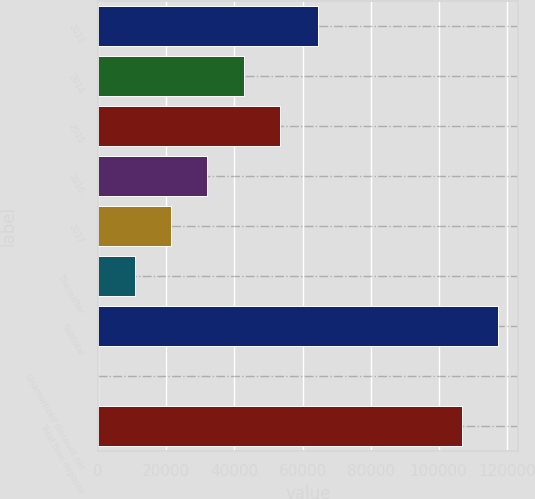Convert chart. <chart><loc_0><loc_0><loc_500><loc_500><bar_chart><fcel>2013<fcel>2014<fcel>2015<fcel>2016<fcel>2017<fcel>Thereafter<fcel>Subtotal<fcel>Unamortized discount net<fcel>Total time deposits<nl><fcel>64676<fcel>42690.4<fcel>53362<fcel>32018.8<fcel>21347.2<fcel>10675.6<fcel>117388<fcel>4<fcel>106716<nl></chart> 